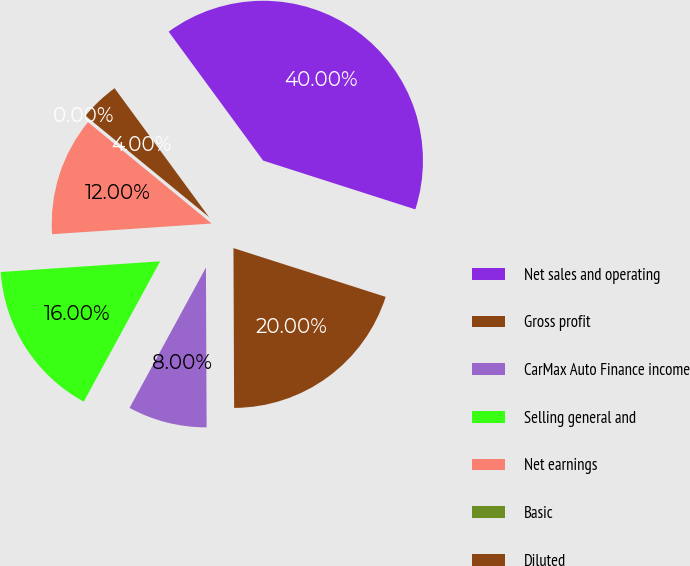Convert chart to OTSL. <chart><loc_0><loc_0><loc_500><loc_500><pie_chart><fcel>Net sales and operating<fcel>Gross profit<fcel>CarMax Auto Finance income<fcel>Selling general and<fcel>Net earnings<fcel>Basic<fcel>Diluted<nl><fcel>40.0%<fcel>20.0%<fcel>8.0%<fcel>16.0%<fcel>12.0%<fcel>0.0%<fcel>4.0%<nl></chart> 